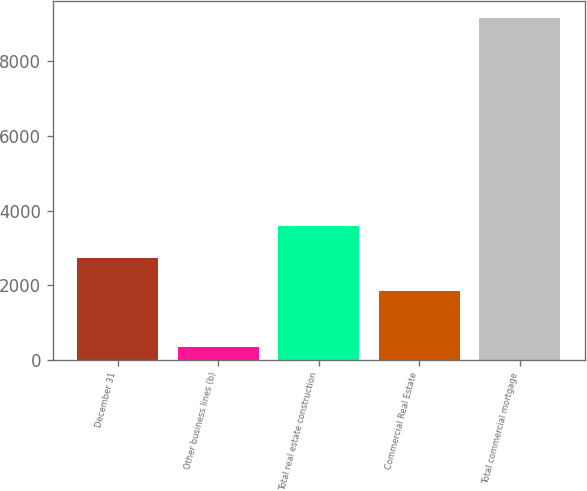<chart> <loc_0><loc_0><loc_500><loc_500><bar_chart><fcel>December 31<fcel>Other business lines (b)<fcel>Total real estate construction<fcel>Commercial Real Estate<fcel>Total commercial mortgage<nl><fcel>2713.8<fcel>331<fcel>3596.6<fcel>1831<fcel>9159<nl></chart> 